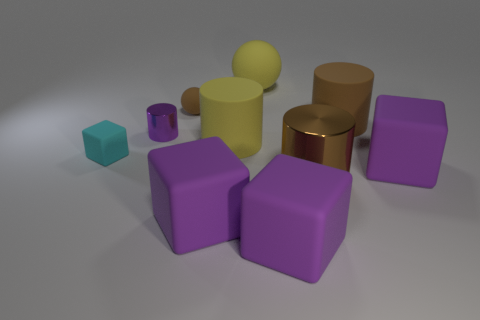How many purple cubes must be subtracted to get 1 purple cubes? 2 Subtract all purple cubes. How many cubes are left? 1 Subtract all purple metallic cylinders. How many cylinders are left? 3 Subtract all yellow spheres. How many purple cubes are left? 3 Add 7 big brown matte cylinders. How many big brown matte cylinders exist? 8 Subtract 0 yellow blocks. How many objects are left? 10 Subtract all cylinders. How many objects are left? 6 Subtract 1 cubes. How many cubes are left? 3 Subtract all gray cylinders. Subtract all red blocks. How many cylinders are left? 4 Subtract all small rubber things. Subtract all brown metallic things. How many objects are left? 7 